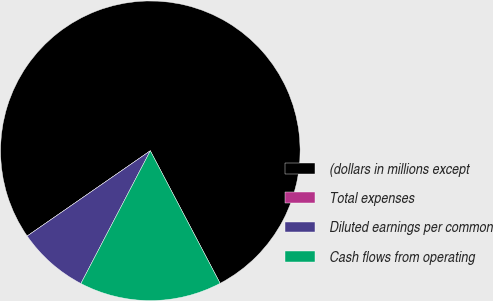<chart> <loc_0><loc_0><loc_500><loc_500><pie_chart><fcel>(dollars in millions except<fcel>Total expenses<fcel>Diluted earnings per common<fcel>Cash flows from operating<nl><fcel>76.92%<fcel>0.0%<fcel>7.69%<fcel>15.38%<nl></chart> 